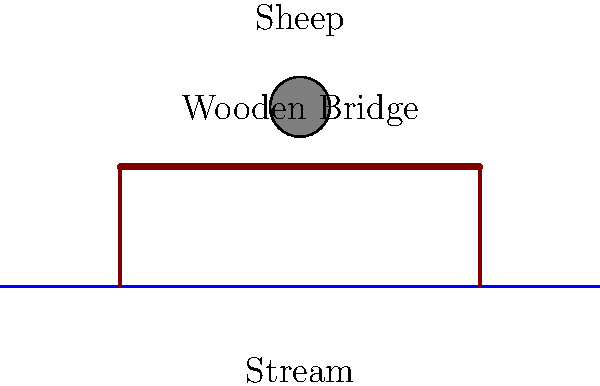You need to move your flock across a small wooden bridge over a stream. The bridge looks old but sturdy. How would you estimate if it's safe for your sheep to cross one by one? To estimate if the bridge is safe for your sheep to cross, follow these steps:

1. Observe the bridge's condition:
   - Look for any visible signs of rot, cracks, or damage in the wood.
   - Check if the support pillars are firmly in place and not leaning.

2. Test the bridge's strength:
   - Walk across the bridge yourself first, listening for any creaking sounds.
   - Feel for any unusual movement or flexing of the planks.

3. Estimate the weight of your sheep:
   - An average sheep weighs about 45-80 kg (100-175 lbs).

4. Compare to your own weight:
   - If you weigh more than an average sheep and the bridge held you safely, it should support a single sheep.

5. Test with one sheep:
   - Guide one sheep across the bridge while watching closely.
   - Observe how the bridge reacts to the sheep's weight.

6. Gradual crossing:
   - If the first sheep crosses safely, allow the rest to cross one at a time.
   - Keep a safe distance between each sheep on the bridge.

By following these steps, you can make a practical estimate of the bridge's safety for your flock without needing any technical knowledge or equipment.
Answer: Test the bridge yourself, then guide sheep across one at a time. 